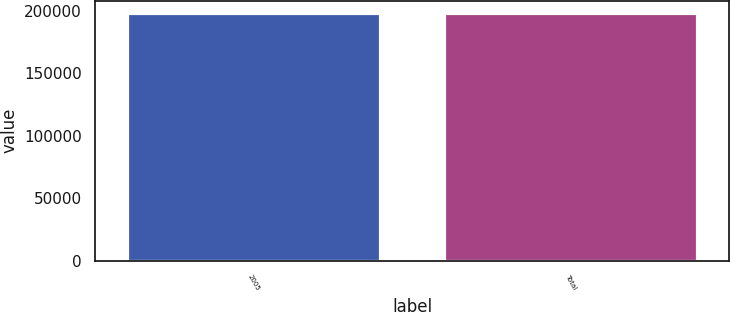Convert chart. <chart><loc_0><loc_0><loc_500><loc_500><bar_chart><fcel>2005<fcel>Total<nl><fcel>198000<fcel>198000<nl></chart> 